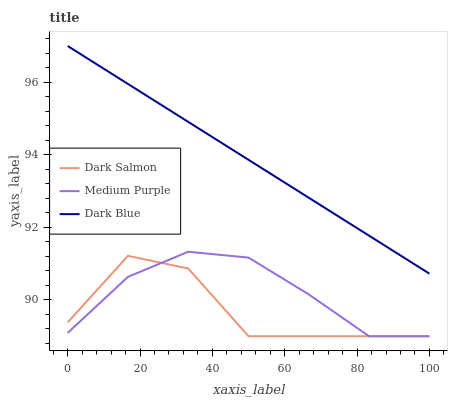Does Dark Salmon have the minimum area under the curve?
Answer yes or no. Yes. Does Dark Blue have the maximum area under the curve?
Answer yes or no. Yes. Does Dark Blue have the minimum area under the curve?
Answer yes or no. No. Does Dark Salmon have the maximum area under the curve?
Answer yes or no. No. Is Dark Blue the smoothest?
Answer yes or no. Yes. Is Dark Salmon the roughest?
Answer yes or no. Yes. Is Dark Salmon the smoothest?
Answer yes or no. No. Is Dark Blue the roughest?
Answer yes or no. No. Does Medium Purple have the lowest value?
Answer yes or no. Yes. Does Dark Blue have the lowest value?
Answer yes or no. No. Does Dark Blue have the highest value?
Answer yes or no. Yes. Does Dark Salmon have the highest value?
Answer yes or no. No. Is Medium Purple less than Dark Blue?
Answer yes or no. Yes. Is Dark Blue greater than Medium Purple?
Answer yes or no. Yes. Does Dark Salmon intersect Medium Purple?
Answer yes or no. Yes. Is Dark Salmon less than Medium Purple?
Answer yes or no. No. Is Dark Salmon greater than Medium Purple?
Answer yes or no. No. Does Medium Purple intersect Dark Blue?
Answer yes or no. No. 